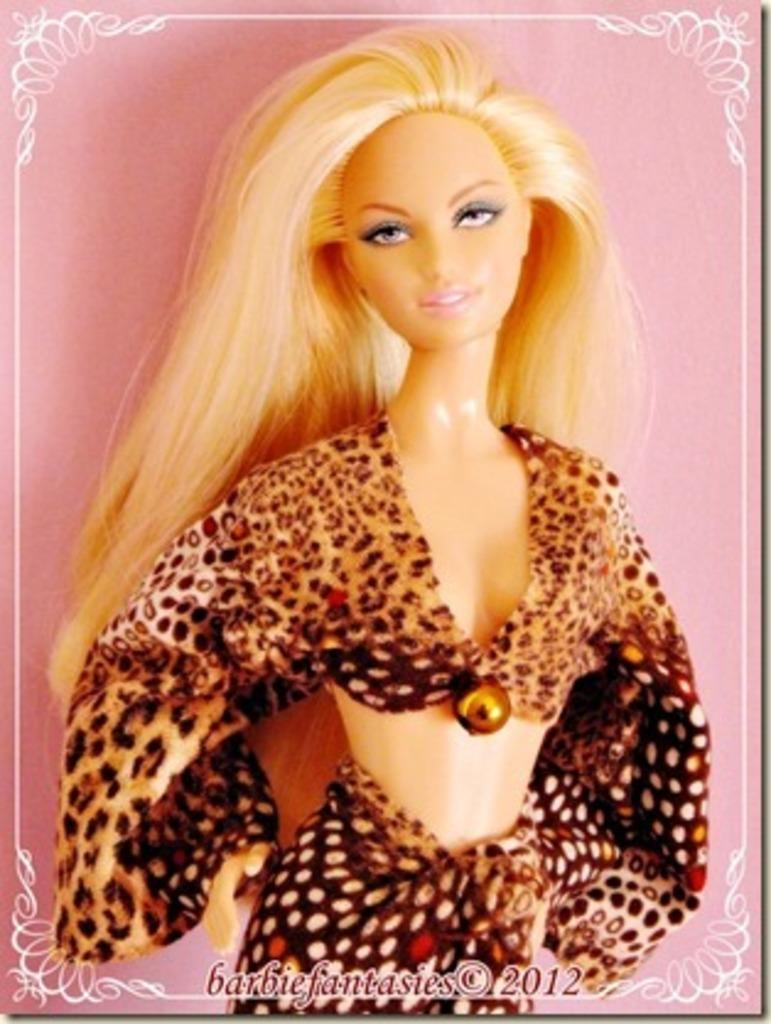What type of doll is present in the image? There is a Barbie doll in the image. What is the doll wearing? The Barbie doll is wearing clothes. Can you describe any additional design elements in the image? Yes, there is a design border in the image. Is there any text or logo visible in the image? Yes, there is a watermark in the image. What type of steel is used to make the knife in the image? There is no knife present in the image. How much powder is needed to clean the doll in the image? There is no mention of cleaning the doll or using powder in the image. 